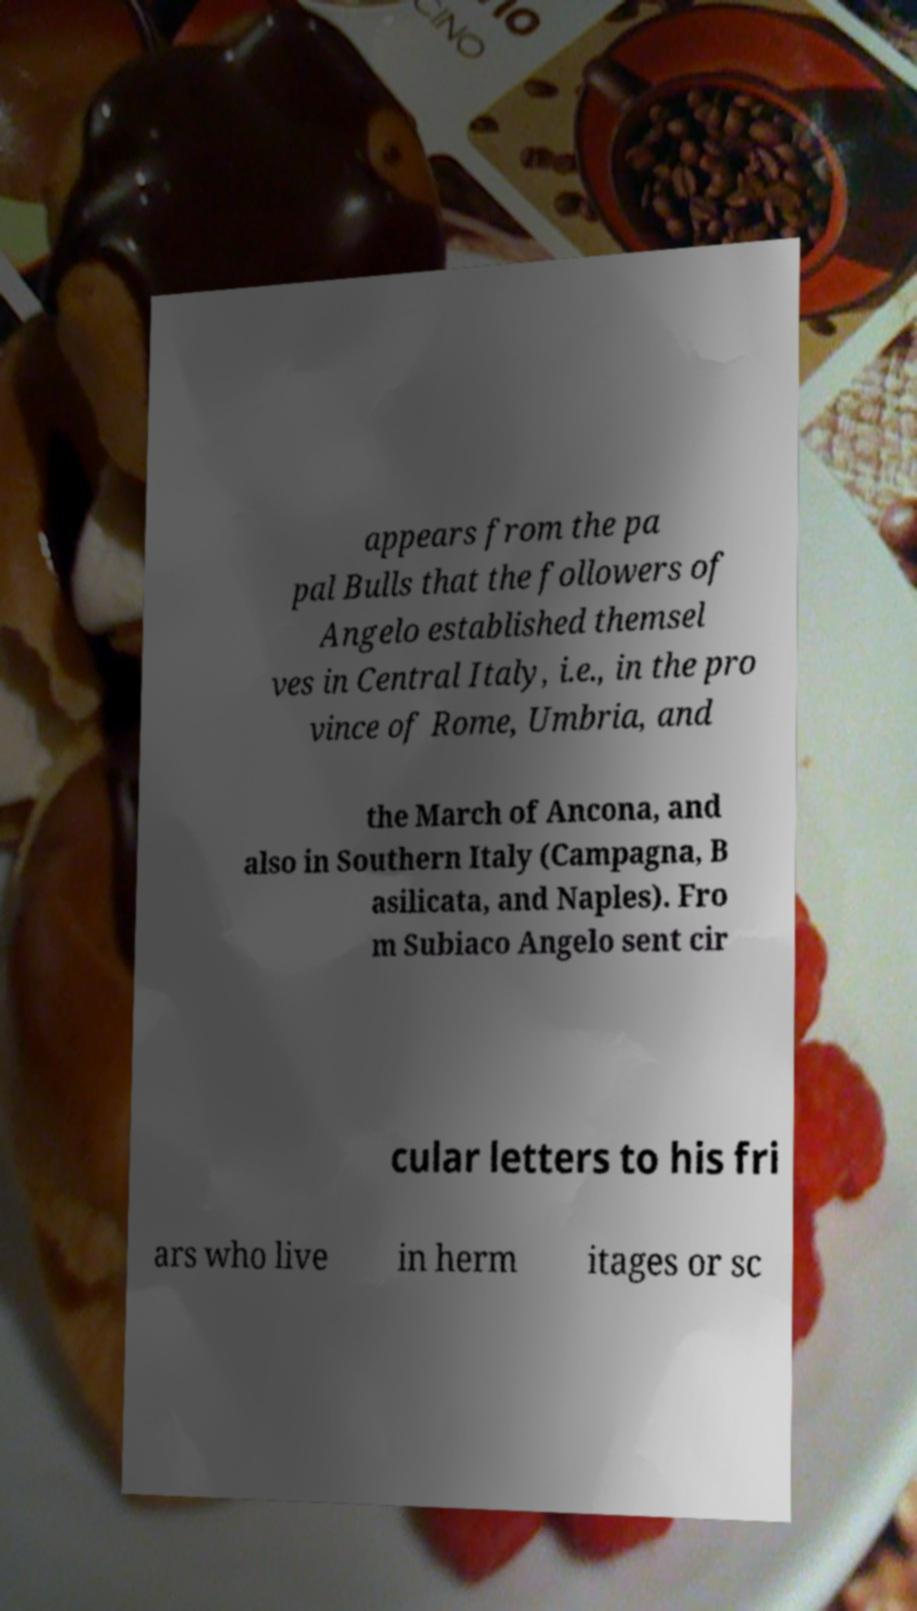Please identify and transcribe the text found in this image. appears from the pa pal Bulls that the followers of Angelo established themsel ves in Central Italy, i.e., in the pro vince of Rome, Umbria, and the March of Ancona, and also in Southern Italy (Campagna, B asilicata, and Naples). Fro m Subiaco Angelo sent cir cular letters to his fri ars who live in herm itages or sc 